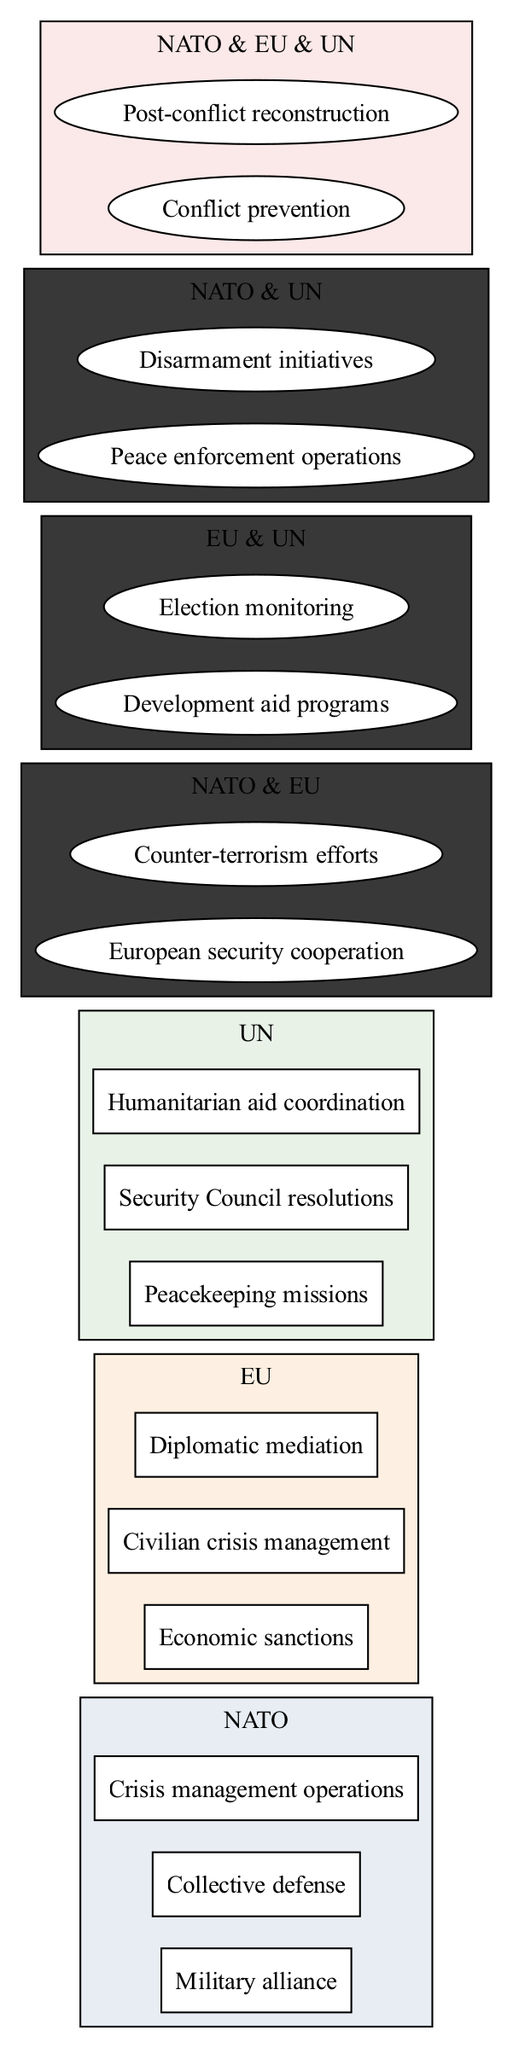What are the elements unique to NATO? The elements unique to NATO can be identified by looking at the section labeled "NATO" in the diagram and noting the elements listed there that are not shared with the other sets. The unique elements are "Military alliance", "Collective defense", and "Crisis management operations".
Answer: Military alliance, Collective defense, Crisis management operations How many elements are there in the UN section? To find the number of elements in the UN section, I will count the items listed under "UN" in the diagram. The elements are "Peacekeeping missions", "Security Council resolutions", and "Humanitarian aid coordination", totaling three elements.
Answer: 3 What element is shared between NATO and EU? To identify the shared element between NATO and EU, I need to look at the intersection of these two sets in the diagram. The elements listed in the intersection are "European security cooperation" and "Counter-terrorism efforts". Therefore, both elements are shared.
Answer: European security cooperation, Counter-terrorism efforts Which organization is involved in "Peacekeeping missions"? The element "Peacekeeping missions" can be found under the UN section in the diagram. This indicates that this specific role is exclusively associated with the UN.
Answer: UN What are the common roles among NATO, EU, and UN? To find the roles common among all three organizations, I need to look at the intersection section labeled "NATO & EU & UN" in the diagram. The elements here are "Conflict prevention" and "Post-conflict reconstruction", highlighting the collaborative efforts of all three organizations.
Answer: Conflict prevention, Post-conflict reconstruction How many unique roles does the EU have compared to NATO? First, I count the unique roles of the EU, which are "Economic sanctions", "Civilian crisis management", and "Diplomatic mediation", totaling three. For NATO's unique roles, there are also three: "Military alliance", "Collective defense", and "Crisis management operations". Thus, there are zero unique roles of the EU compared to NATO since both have three unique roles.
Answer: 0 Which organization primarily coordinates humanitarian aid? By identifying the role associated with humanitarian aid in the diagram, I can see that "Humanitarian aid coordination" is listed specifically under the UN section. This indicates that the UN is primarily responsible for this role.
Answer: UN What are the shared elements between EU and UN? To determine the shared elements between EU and UN, I must refer to the intersection where these two sets overlap. The elements present are "Development aid programs" and "Election monitoring". This shows that both organizations have roles in these areas.
Answer: Development aid programs, Election monitoring 